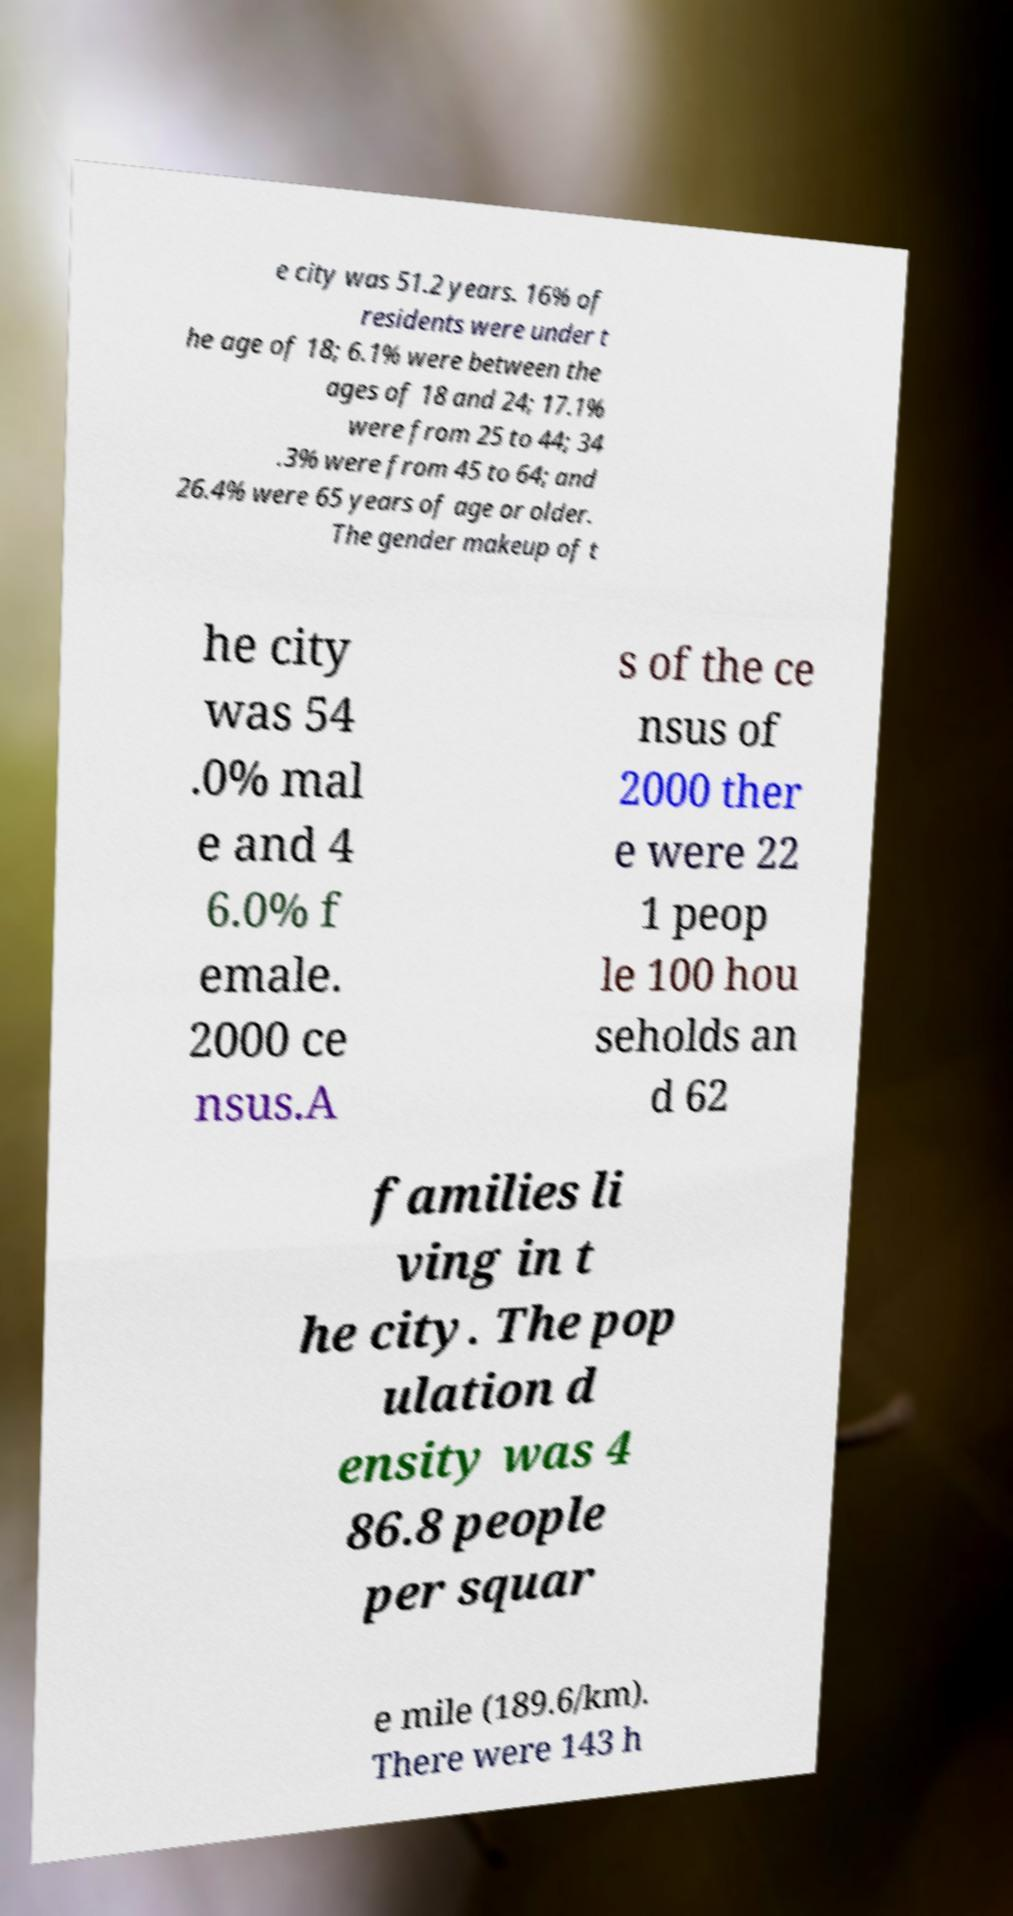Please identify and transcribe the text found in this image. e city was 51.2 years. 16% of residents were under t he age of 18; 6.1% were between the ages of 18 and 24; 17.1% were from 25 to 44; 34 .3% were from 45 to 64; and 26.4% were 65 years of age or older. The gender makeup of t he city was 54 .0% mal e and 4 6.0% f emale. 2000 ce nsus.A s of the ce nsus of 2000 ther e were 22 1 peop le 100 hou seholds an d 62 families li ving in t he city. The pop ulation d ensity was 4 86.8 people per squar e mile (189.6/km). There were 143 h 